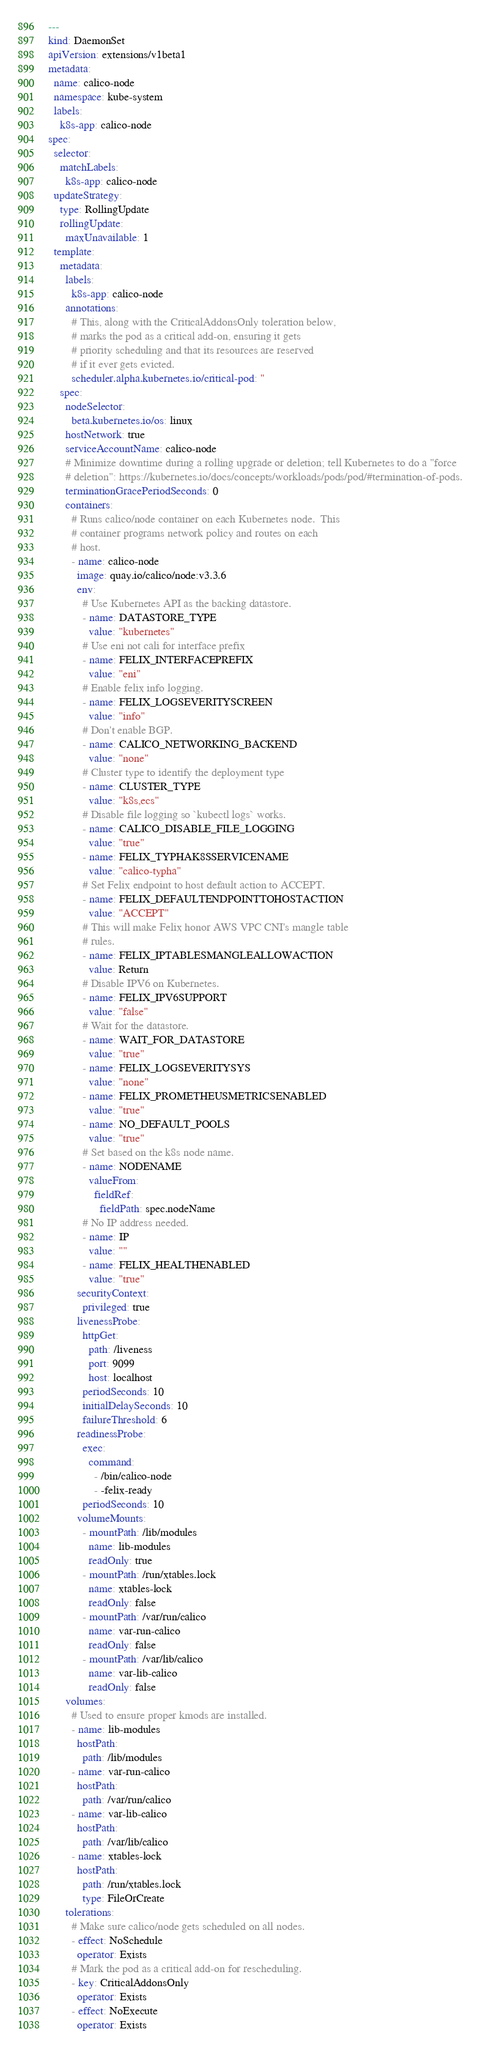Convert code to text. <code><loc_0><loc_0><loc_500><loc_500><_YAML_>---
kind: DaemonSet
apiVersion: extensions/v1beta1
metadata:
  name: calico-node
  namespace: kube-system
  labels:
    k8s-app: calico-node
spec:
  selector:
    matchLabels:
      k8s-app: calico-node
  updateStrategy:
    type: RollingUpdate
    rollingUpdate:
      maxUnavailable: 1
  template:
    metadata:
      labels:
        k8s-app: calico-node
      annotations:
        # This, along with the CriticalAddonsOnly toleration below,
        # marks the pod as a critical add-on, ensuring it gets
        # priority scheduling and that its resources are reserved
        # if it ever gets evicted.
        scheduler.alpha.kubernetes.io/critical-pod: ''
    spec:
      nodeSelector:
        beta.kubernetes.io/os: linux
      hostNetwork: true
      serviceAccountName: calico-node
      # Minimize downtime during a rolling upgrade or deletion; tell Kubernetes to do a "force
      # deletion": https://kubernetes.io/docs/concepts/workloads/pods/pod/#termination-of-pods.
      terminationGracePeriodSeconds: 0
      containers:
        # Runs calico/node container on each Kubernetes node.  This
        # container programs network policy and routes on each
        # host.
        - name: calico-node
          image: quay.io/calico/node:v3.3.6
          env:
            # Use Kubernetes API as the backing datastore.
            - name: DATASTORE_TYPE
              value: "kubernetes"
            # Use eni not cali for interface prefix
            - name: FELIX_INTERFACEPREFIX
              value: "eni"
            # Enable felix info logging.
            - name: FELIX_LOGSEVERITYSCREEN
              value: "info"
            # Don't enable BGP.
            - name: CALICO_NETWORKING_BACKEND
              value: "none"
            # Cluster type to identify the deployment type
            - name: CLUSTER_TYPE
              value: "k8s,ecs"
            # Disable file logging so `kubectl logs` works.
            - name: CALICO_DISABLE_FILE_LOGGING
              value: "true"
            - name: FELIX_TYPHAK8SSERVICENAME
              value: "calico-typha"
            # Set Felix endpoint to host default action to ACCEPT.
            - name: FELIX_DEFAULTENDPOINTTOHOSTACTION
              value: "ACCEPT"
            # This will make Felix honor AWS VPC CNI's mangle table
            # rules.
            - name: FELIX_IPTABLESMANGLEALLOWACTION
              value: Return
            # Disable IPV6 on Kubernetes.
            - name: FELIX_IPV6SUPPORT
              value: "false"
            # Wait for the datastore.
            - name: WAIT_FOR_DATASTORE
              value: "true"
            - name: FELIX_LOGSEVERITYSYS
              value: "none"
            - name: FELIX_PROMETHEUSMETRICSENABLED
              value: "true"
            - name: NO_DEFAULT_POOLS
              value: "true"
            # Set based on the k8s node name.
            - name: NODENAME
              valueFrom:
                fieldRef:
                  fieldPath: spec.nodeName
            # No IP address needed.
            - name: IP
              value: ""
            - name: FELIX_HEALTHENABLED
              value: "true"
          securityContext:
            privileged: true
          livenessProbe:
            httpGet:
              path: /liveness
              port: 9099
              host: localhost
            periodSeconds: 10
            initialDelaySeconds: 10
            failureThreshold: 6
          readinessProbe:
            exec:
              command:
                - /bin/calico-node
                - -felix-ready
            periodSeconds: 10
          volumeMounts:
            - mountPath: /lib/modules
              name: lib-modules
              readOnly: true
            - mountPath: /run/xtables.lock
              name: xtables-lock
              readOnly: false
            - mountPath: /var/run/calico
              name: var-run-calico
              readOnly: false
            - mountPath: /var/lib/calico
              name: var-lib-calico
              readOnly: false
      volumes:
        # Used to ensure proper kmods are installed.
        - name: lib-modules
          hostPath:
            path: /lib/modules
        - name: var-run-calico
          hostPath:
            path: /var/run/calico
        - name: var-lib-calico
          hostPath:
            path: /var/lib/calico
        - name: xtables-lock
          hostPath:
            path: /run/xtables.lock
            type: FileOrCreate
      tolerations:
        # Make sure calico/node gets scheduled on all nodes.
        - effect: NoSchedule
          operator: Exists
        # Mark the pod as a critical add-on for rescheduling.
        - key: CriticalAddonsOnly
          operator: Exists
        - effect: NoExecute
          operator: Exists
</code> 